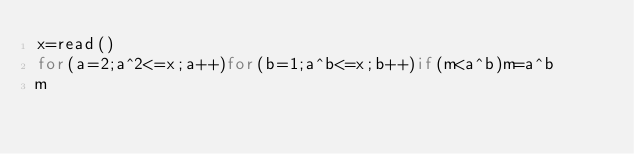<code> <loc_0><loc_0><loc_500><loc_500><_bc_>x=read()
for(a=2;a^2<=x;a++)for(b=1;a^b<=x;b++)if(m<a^b)m=a^b
m
</code> 